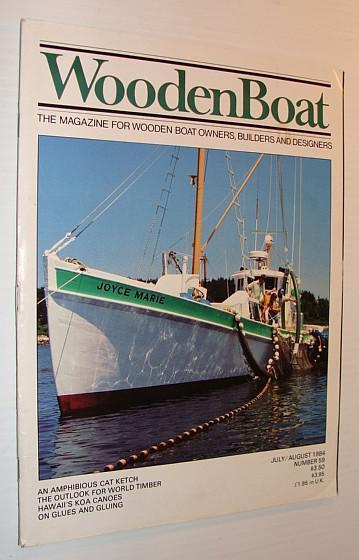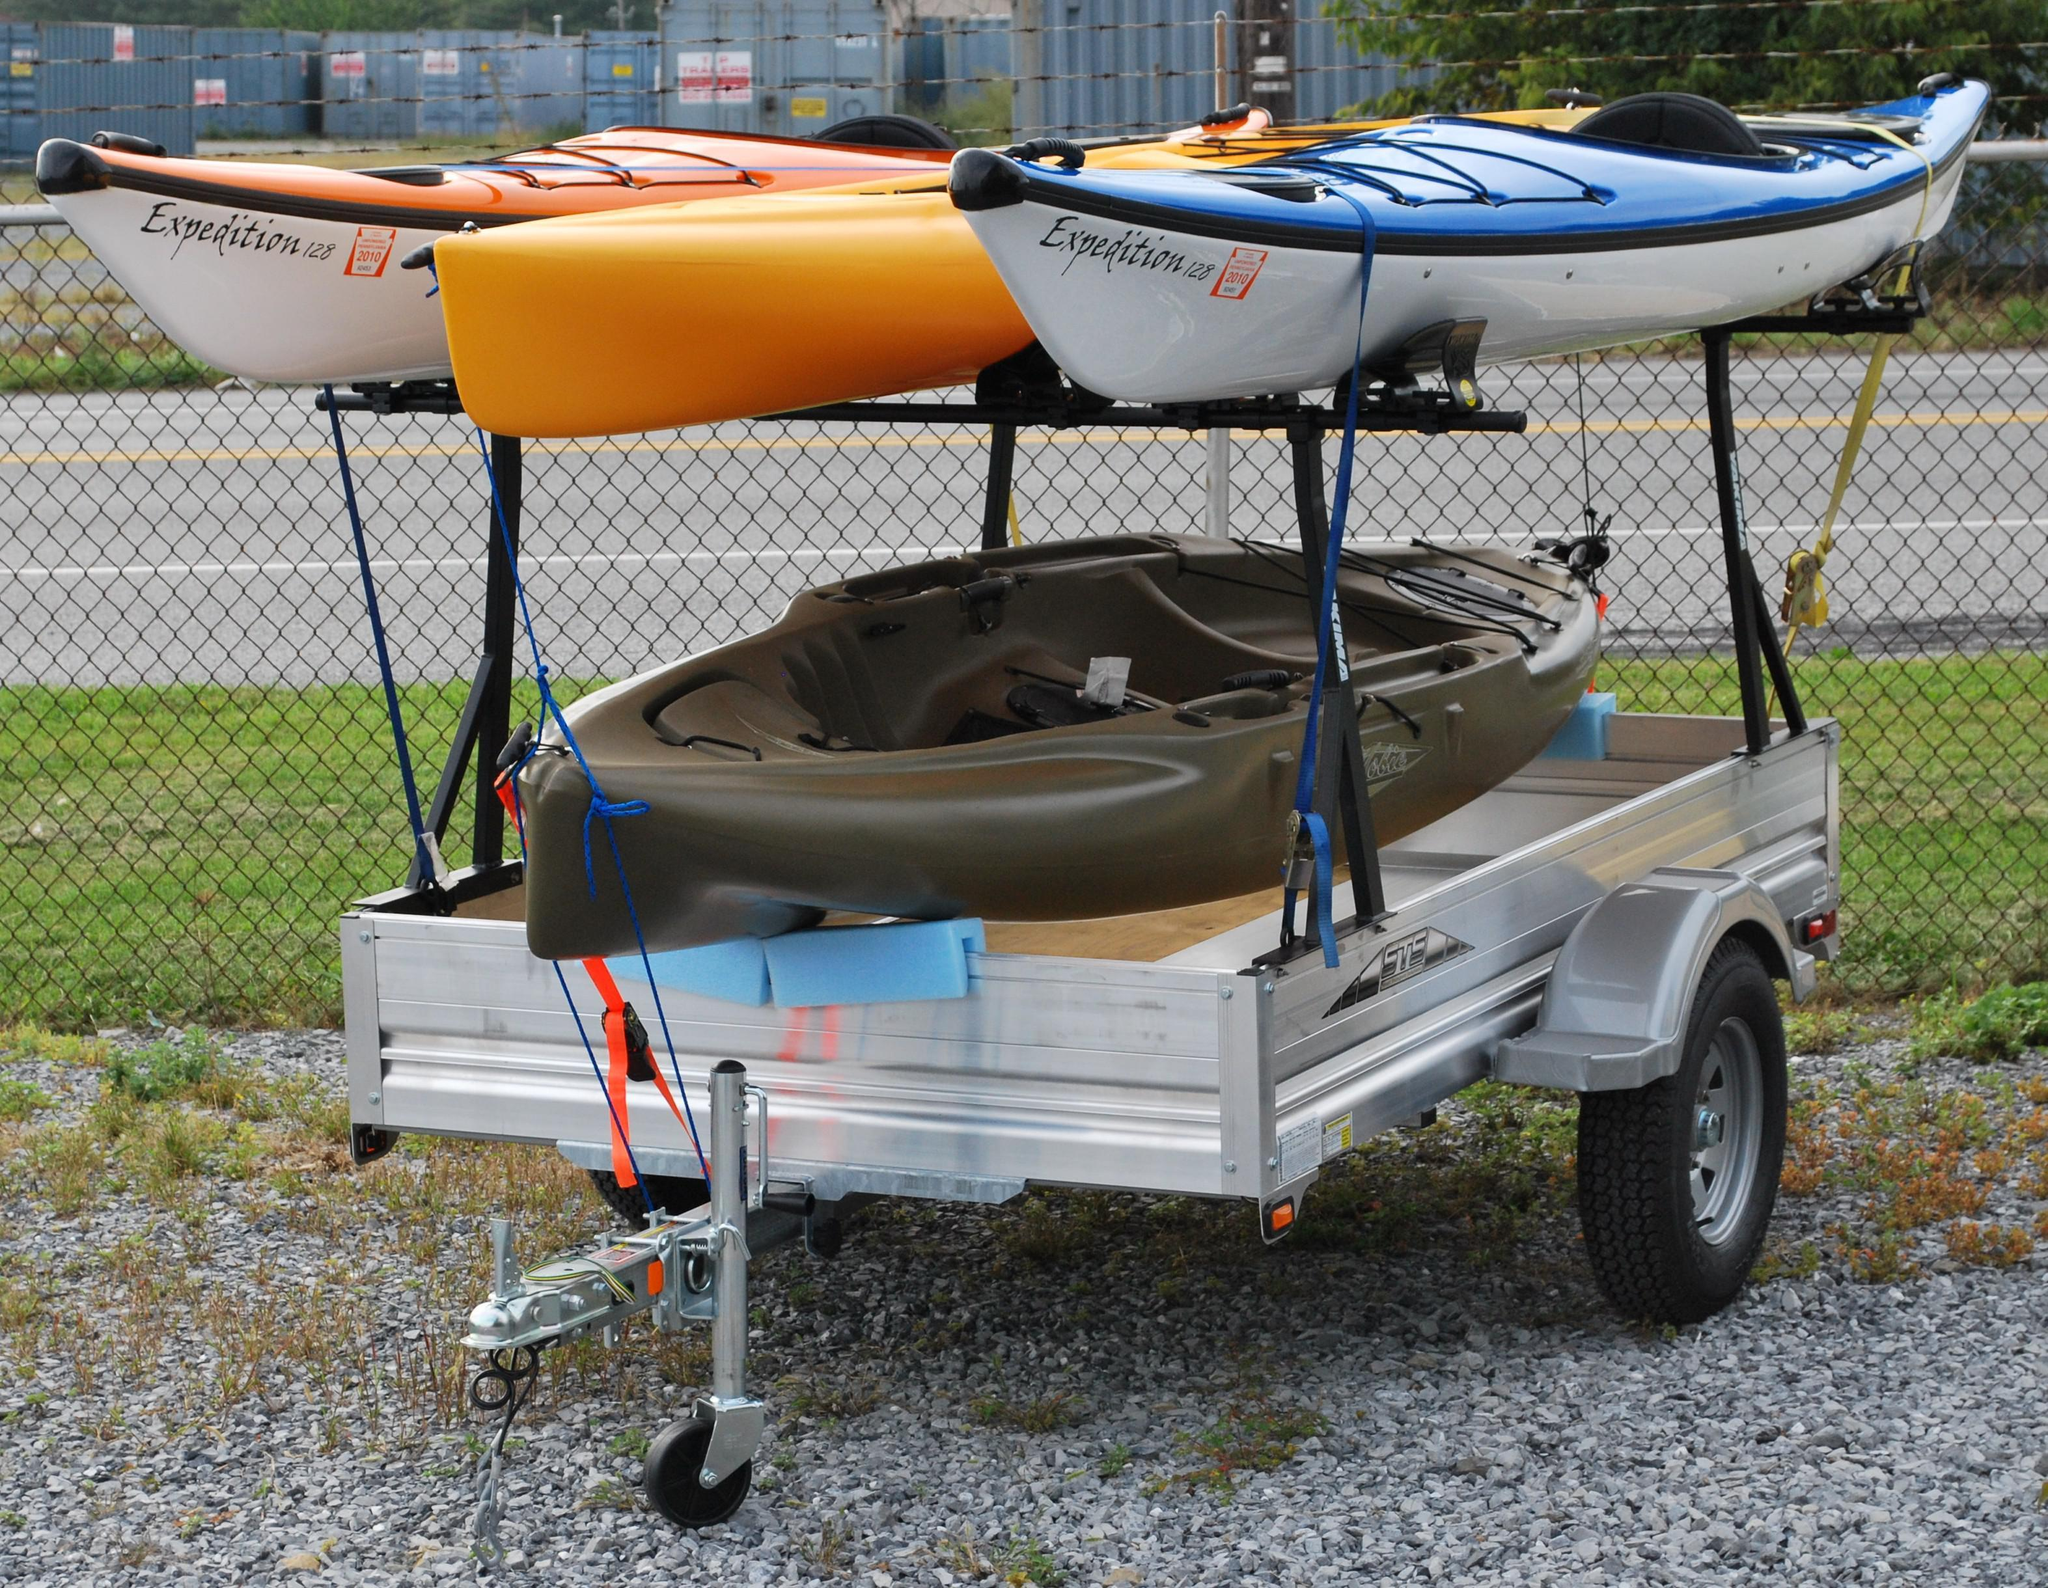The first image is the image on the left, the second image is the image on the right. For the images shown, is this caption "An image of a trailer includes two boats and a bicycle." true? Answer yes or no. No. 